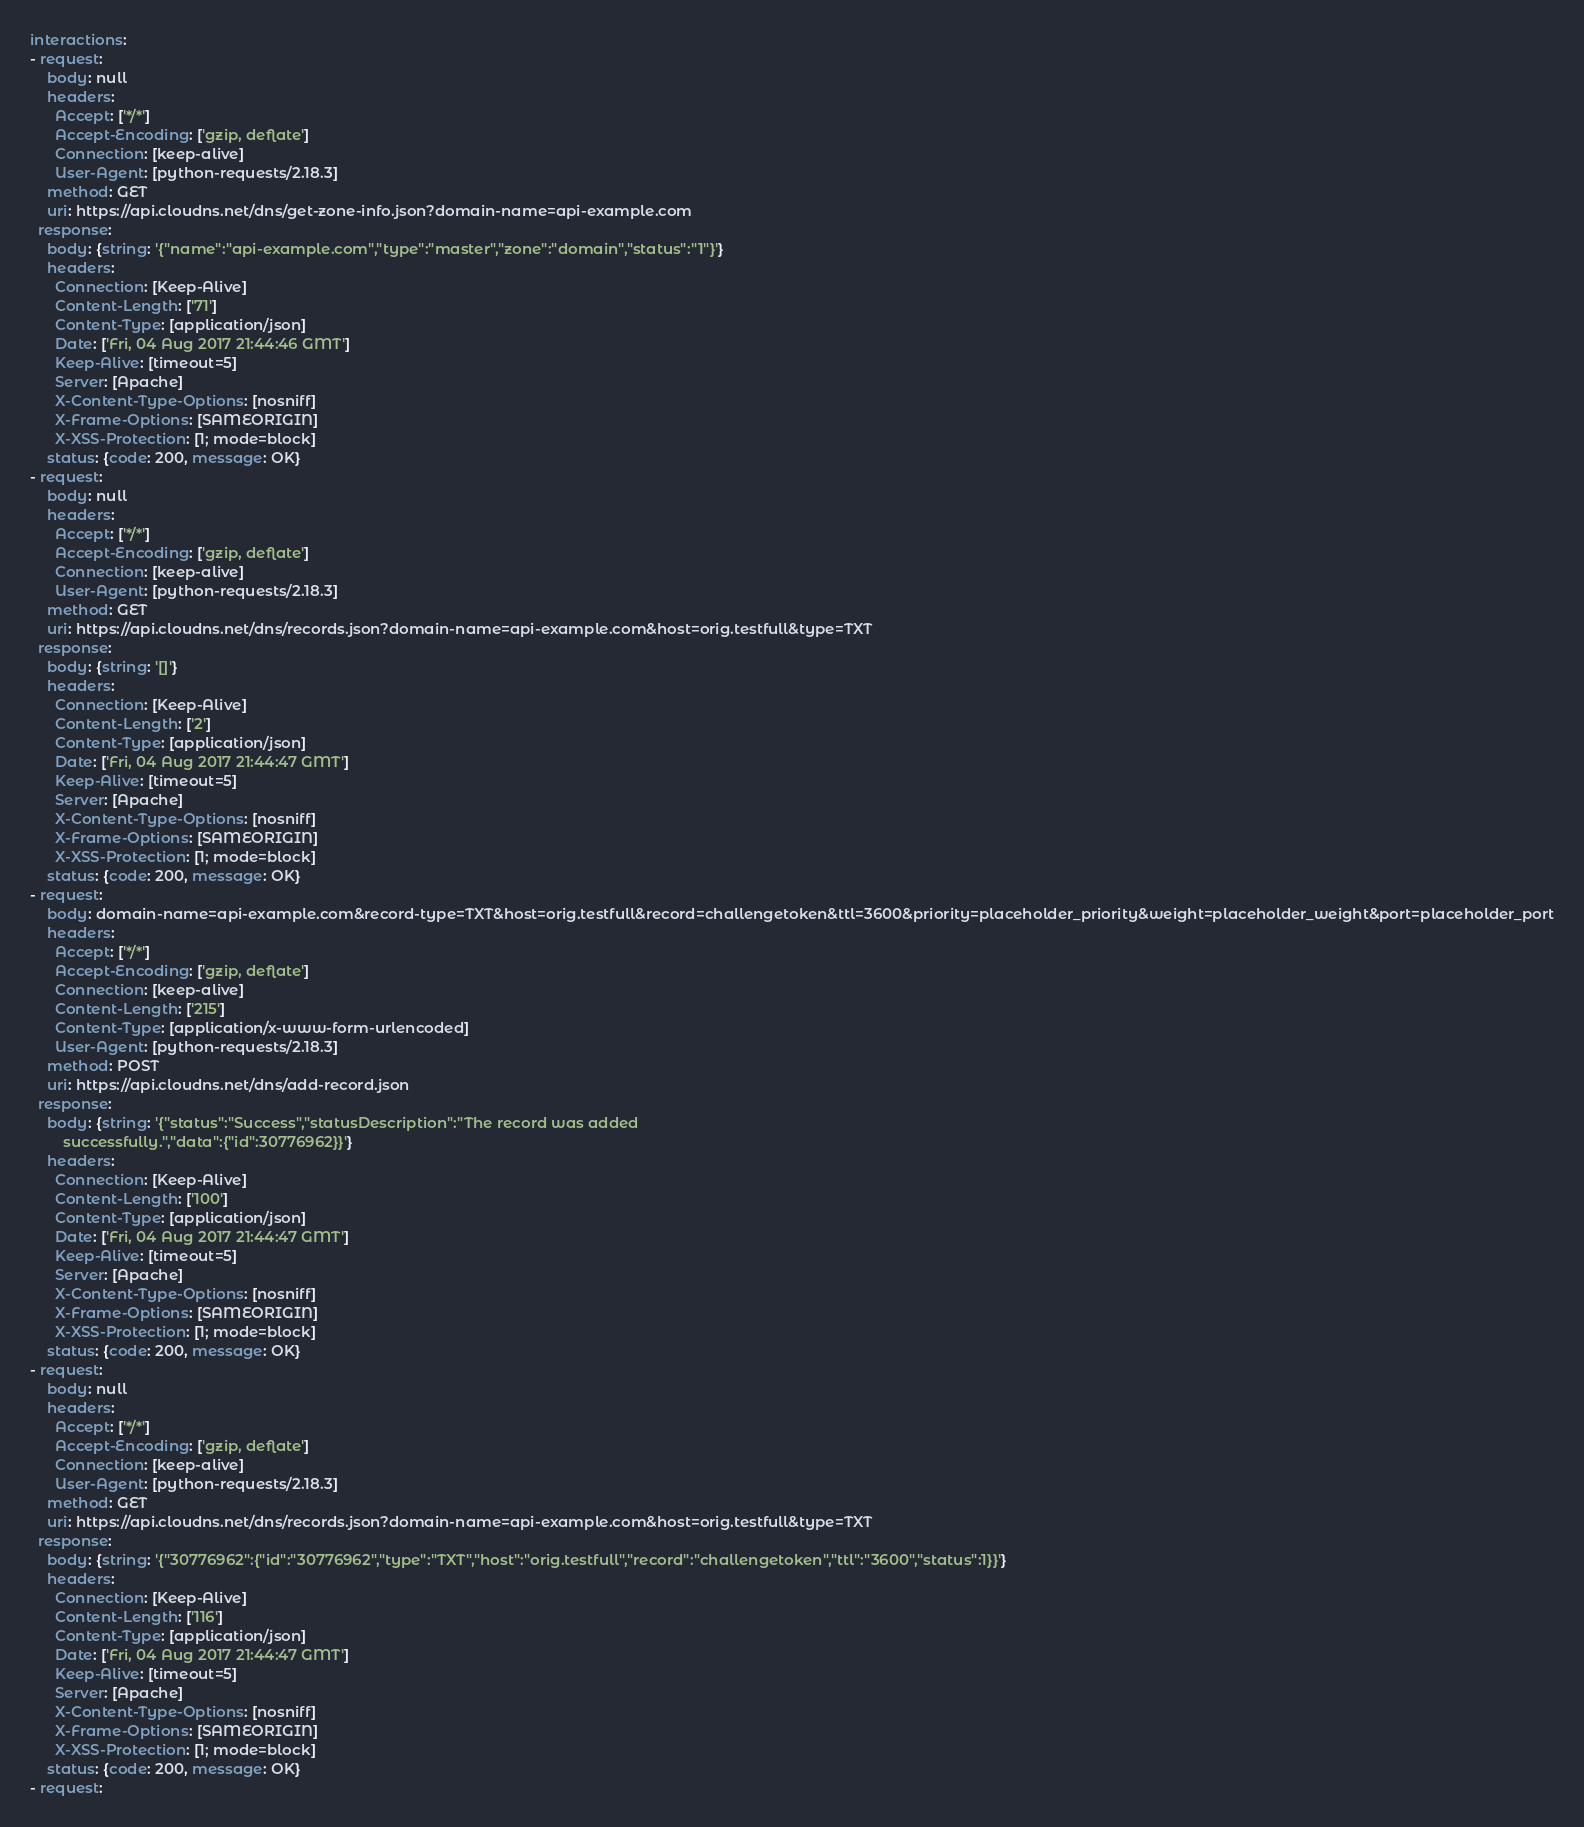Convert code to text. <code><loc_0><loc_0><loc_500><loc_500><_YAML_>interactions:
- request:
    body: null
    headers:
      Accept: ['*/*']
      Accept-Encoding: ['gzip, deflate']
      Connection: [keep-alive]
      User-Agent: [python-requests/2.18.3]
    method: GET
    uri: https://api.cloudns.net/dns/get-zone-info.json?domain-name=api-example.com
  response:
    body: {string: '{"name":"api-example.com","type":"master","zone":"domain","status":"1"}'}
    headers:
      Connection: [Keep-Alive]
      Content-Length: ['71']
      Content-Type: [application/json]
      Date: ['Fri, 04 Aug 2017 21:44:46 GMT']
      Keep-Alive: [timeout=5]
      Server: [Apache]
      X-Content-Type-Options: [nosniff]
      X-Frame-Options: [SAMEORIGIN]
      X-XSS-Protection: [1; mode=block]
    status: {code: 200, message: OK}
- request:
    body: null
    headers:
      Accept: ['*/*']
      Accept-Encoding: ['gzip, deflate']
      Connection: [keep-alive]
      User-Agent: [python-requests/2.18.3]
    method: GET
    uri: https://api.cloudns.net/dns/records.json?domain-name=api-example.com&host=orig.testfull&type=TXT
  response:
    body: {string: '[]'}
    headers:
      Connection: [Keep-Alive]
      Content-Length: ['2']
      Content-Type: [application/json]
      Date: ['Fri, 04 Aug 2017 21:44:47 GMT']
      Keep-Alive: [timeout=5]
      Server: [Apache]
      X-Content-Type-Options: [nosniff]
      X-Frame-Options: [SAMEORIGIN]
      X-XSS-Protection: [1; mode=block]
    status: {code: 200, message: OK}
- request:
    body: domain-name=api-example.com&record-type=TXT&host=orig.testfull&record=challengetoken&ttl=3600&priority=placeholder_priority&weight=placeholder_weight&port=placeholder_port
    headers:
      Accept: ['*/*']
      Accept-Encoding: ['gzip, deflate']
      Connection: [keep-alive]
      Content-Length: ['215']
      Content-Type: [application/x-www-form-urlencoded]
      User-Agent: [python-requests/2.18.3]
    method: POST
    uri: https://api.cloudns.net/dns/add-record.json
  response:
    body: {string: '{"status":"Success","statusDescription":"The record was added
        successfully.","data":{"id":30776962}}'}
    headers:
      Connection: [Keep-Alive]
      Content-Length: ['100']
      Content-Type: [application/json]
      Date: ['Fri, 04 Aug 2017 21:44:47 GMT']
      Keep-Alive: [timeout=5]
      Server: [Apache]
      X-Content-Type-Options: [nosniff]
      X-Frame-Options: [SAMEORIGIN]
      X-XSS-Protection: [1; mode=block]
    status: {code: 200, message: OK}
- request:
    body: null
    headers:
      Accept: ['*/*']
      Accept-Encoding: ['gzip, deflate']
      Connection: [keep-alive]
      User-Agent: [python-requests/2.18.3]
    method: GET
    uri: https://api.cloudns.net/dns/records.json?domain-name=api-example.com&host=orig.testfull&type=TXT
  response:
    body: {string: '{"30776962":{"id":"30776962","type":"TXT","host":"orig.testfull","record":"challengetoken","ttl":"3600","status":1}}'}
    headers:
      Connection: [Keep-Alive]
      Content-Length: ['116']
      Content-Type: [application/json]
      Date: ['Fri, 04 Aug 2017 21:44:47 GMT']
      Keep-Alive: [timeout=5]
      Server: [Apache]
      X-Content-Type-Options: [nosniff]
      X-Frame-Options: [SAMEORIGIN]
      X-XSS-Protection: [1; mode=block]
    status: {code: 200, message: OK}
- request:</code> 